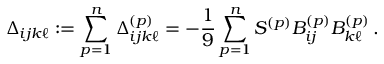Convert formula to latex. <formula><loc_0><loc_0><loc_500><loc_500>\Delta _ { i j k \ell } \colon = \sum _ { p = 1 } ^ { n } \Delta _ { i j k \ell } ^ { ( p ) } = - \frac { 1 } { 9 } \sum _ { p = 1 } ^ { n } S ^ { ( p ) } B _ { i j } ^ { ( p ) } B _ { k \ell } ^ { ( p ) } \, .</formula> 